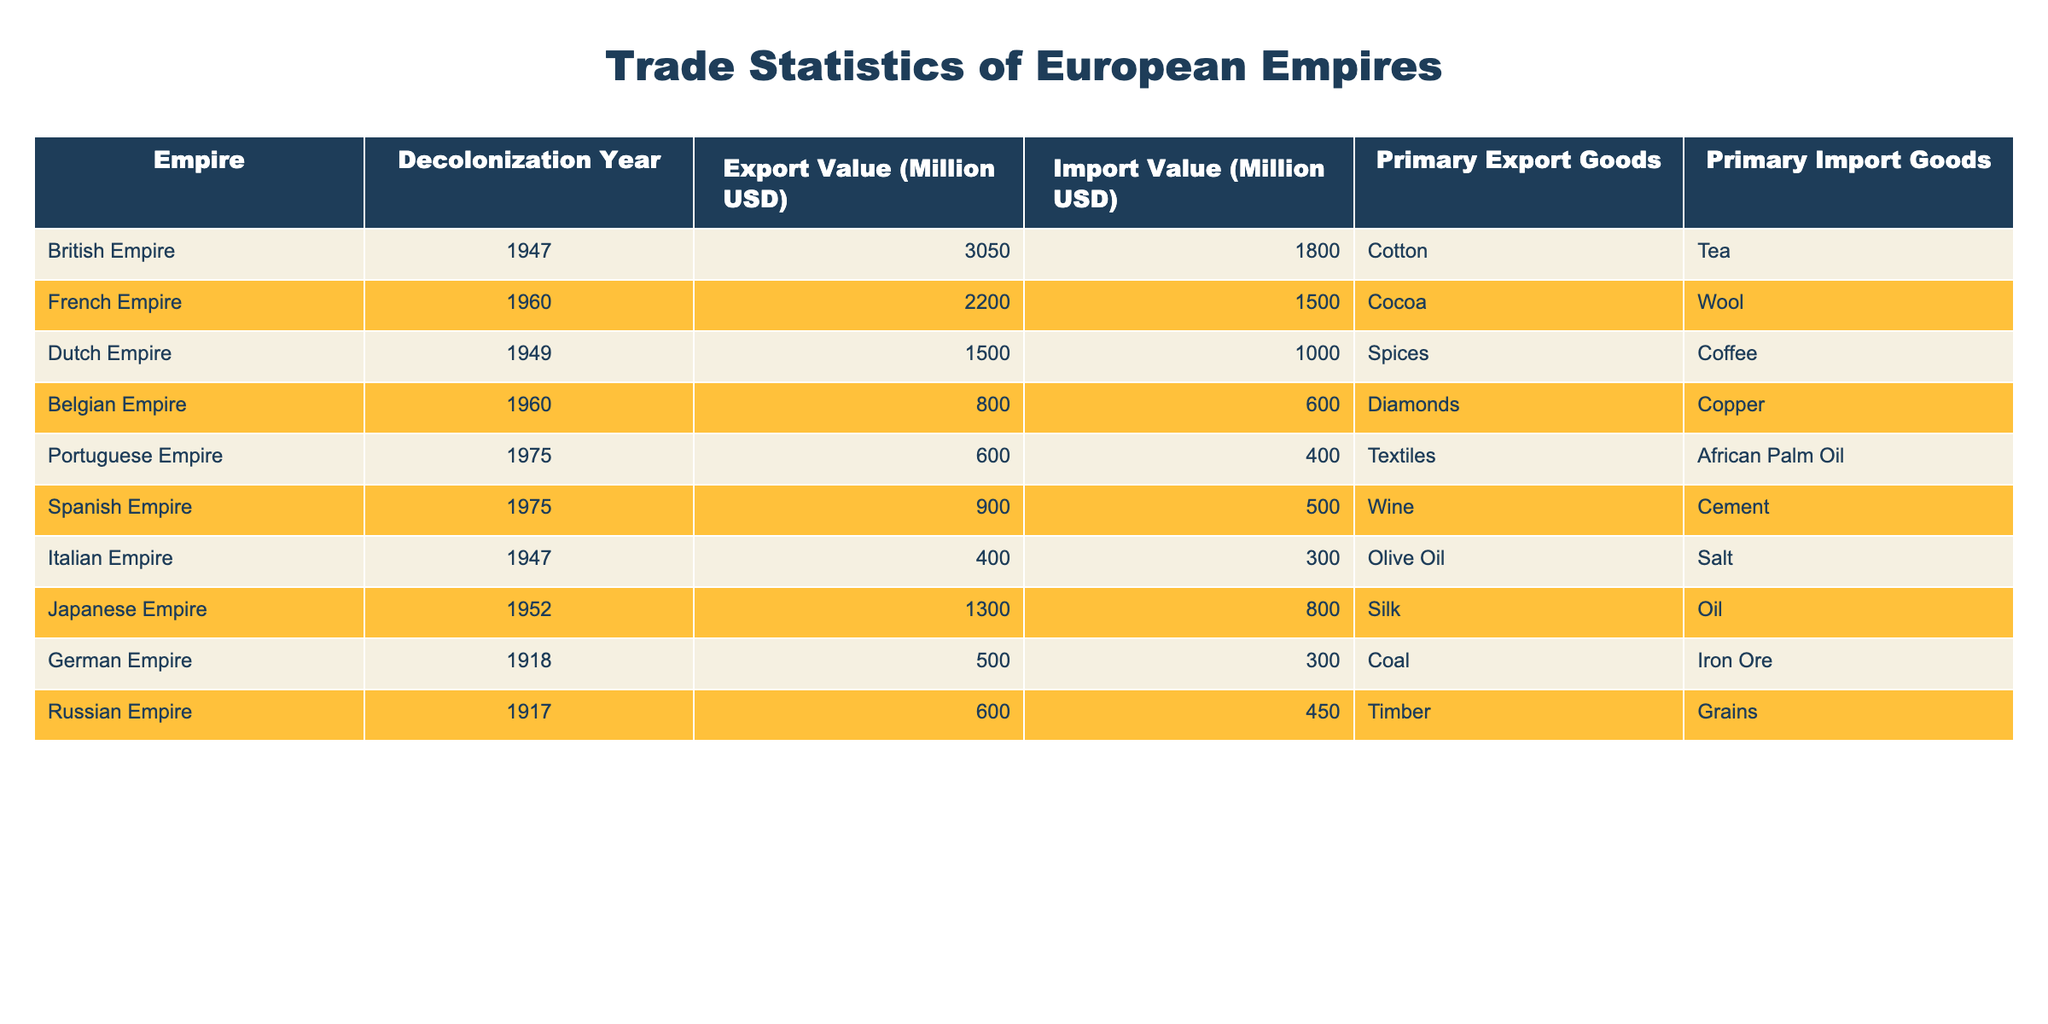What was the export value of the British Empire in 1947? The table shows that the export value for the British Empire in 1947 is 3050 million USD, which is directly provided in the row corresponding to the British Empire.
Answer: 3050 million USD Which empire had the highest import value after decolonization? By examining the import values, the British Empire has an import value of 1800 million USD, which is the highest when compared to others listed in the table.
Answer: British Empire What are the primary export goods of the French Empire? Referring to the row for the French Empire, the primary export goods listed are cocoa.
Answer: Cocoa Which empire had the lowest export value after decolonization? The table indicates that the Portuguese Empire had the lowest export value at 600 million USD compared to the other empires listed.
Answer: Portuguese Empire Is it true that the Italian Empire imported more than it exported in 1947? Looking at the table for the Italian Empire, the export value is 400 million USD and the import value is 300 million USD. Since the export value is greater than the import value, the statement is false.
Answer: No What was the combined export value of the German and Russian Empires? The export value for the German Empire is 500 million USD and for the Russian Empire is 600 million USD. Adding these values together results in 500 + 600 = 1100 million USD.
Answer: 1100 million USD What is the difference between the export values of the Spanish Empire and the Belgian Empire? The export value for the Spanish Empire is 900 million USD and for the Belgian Empire is 800 million USD. Calculating the difference gives 900 - 800 = 100 million USD.
Answer: 100 million USD Which empire had a primary import good of iron ore? The table lists that the German Empire had iron ore as its primary import good. This is directly taken from the information provided for that empire.
Answer: German Empire What was the average import value among all listed empires? The import values are 1800, 1500, 1000, 600, 400, 500, 800, 300, and 450 million USD. Summing these values gives a total of 6100 million USD, and there are 9 empires, so the average is 6100 / 9, which is approximately 677.78 million USD.
Answer: 677.78 million USD 